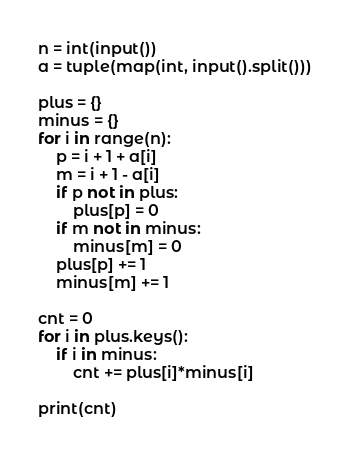Convert code to text. <code><loc_0><loc_0><loc_500><loc_500><_Python_>n = int(input())
a = tuple(map(int, input().split()))

plus = {}
minus = {}
for i in range(n):
    p = i + 1 + a[i]
    m = i + 1 - a[i]
    if p not in plus:
        plus[p] = 0
    if m not in minus:
        minus[m] = 0
    plus[p] += 1
    minus[m] += 1

cnt = 0
for i in plus.keys():
    if i in minus:
        cnt += plus[i]*minus[i]

print(cnt)</code> 